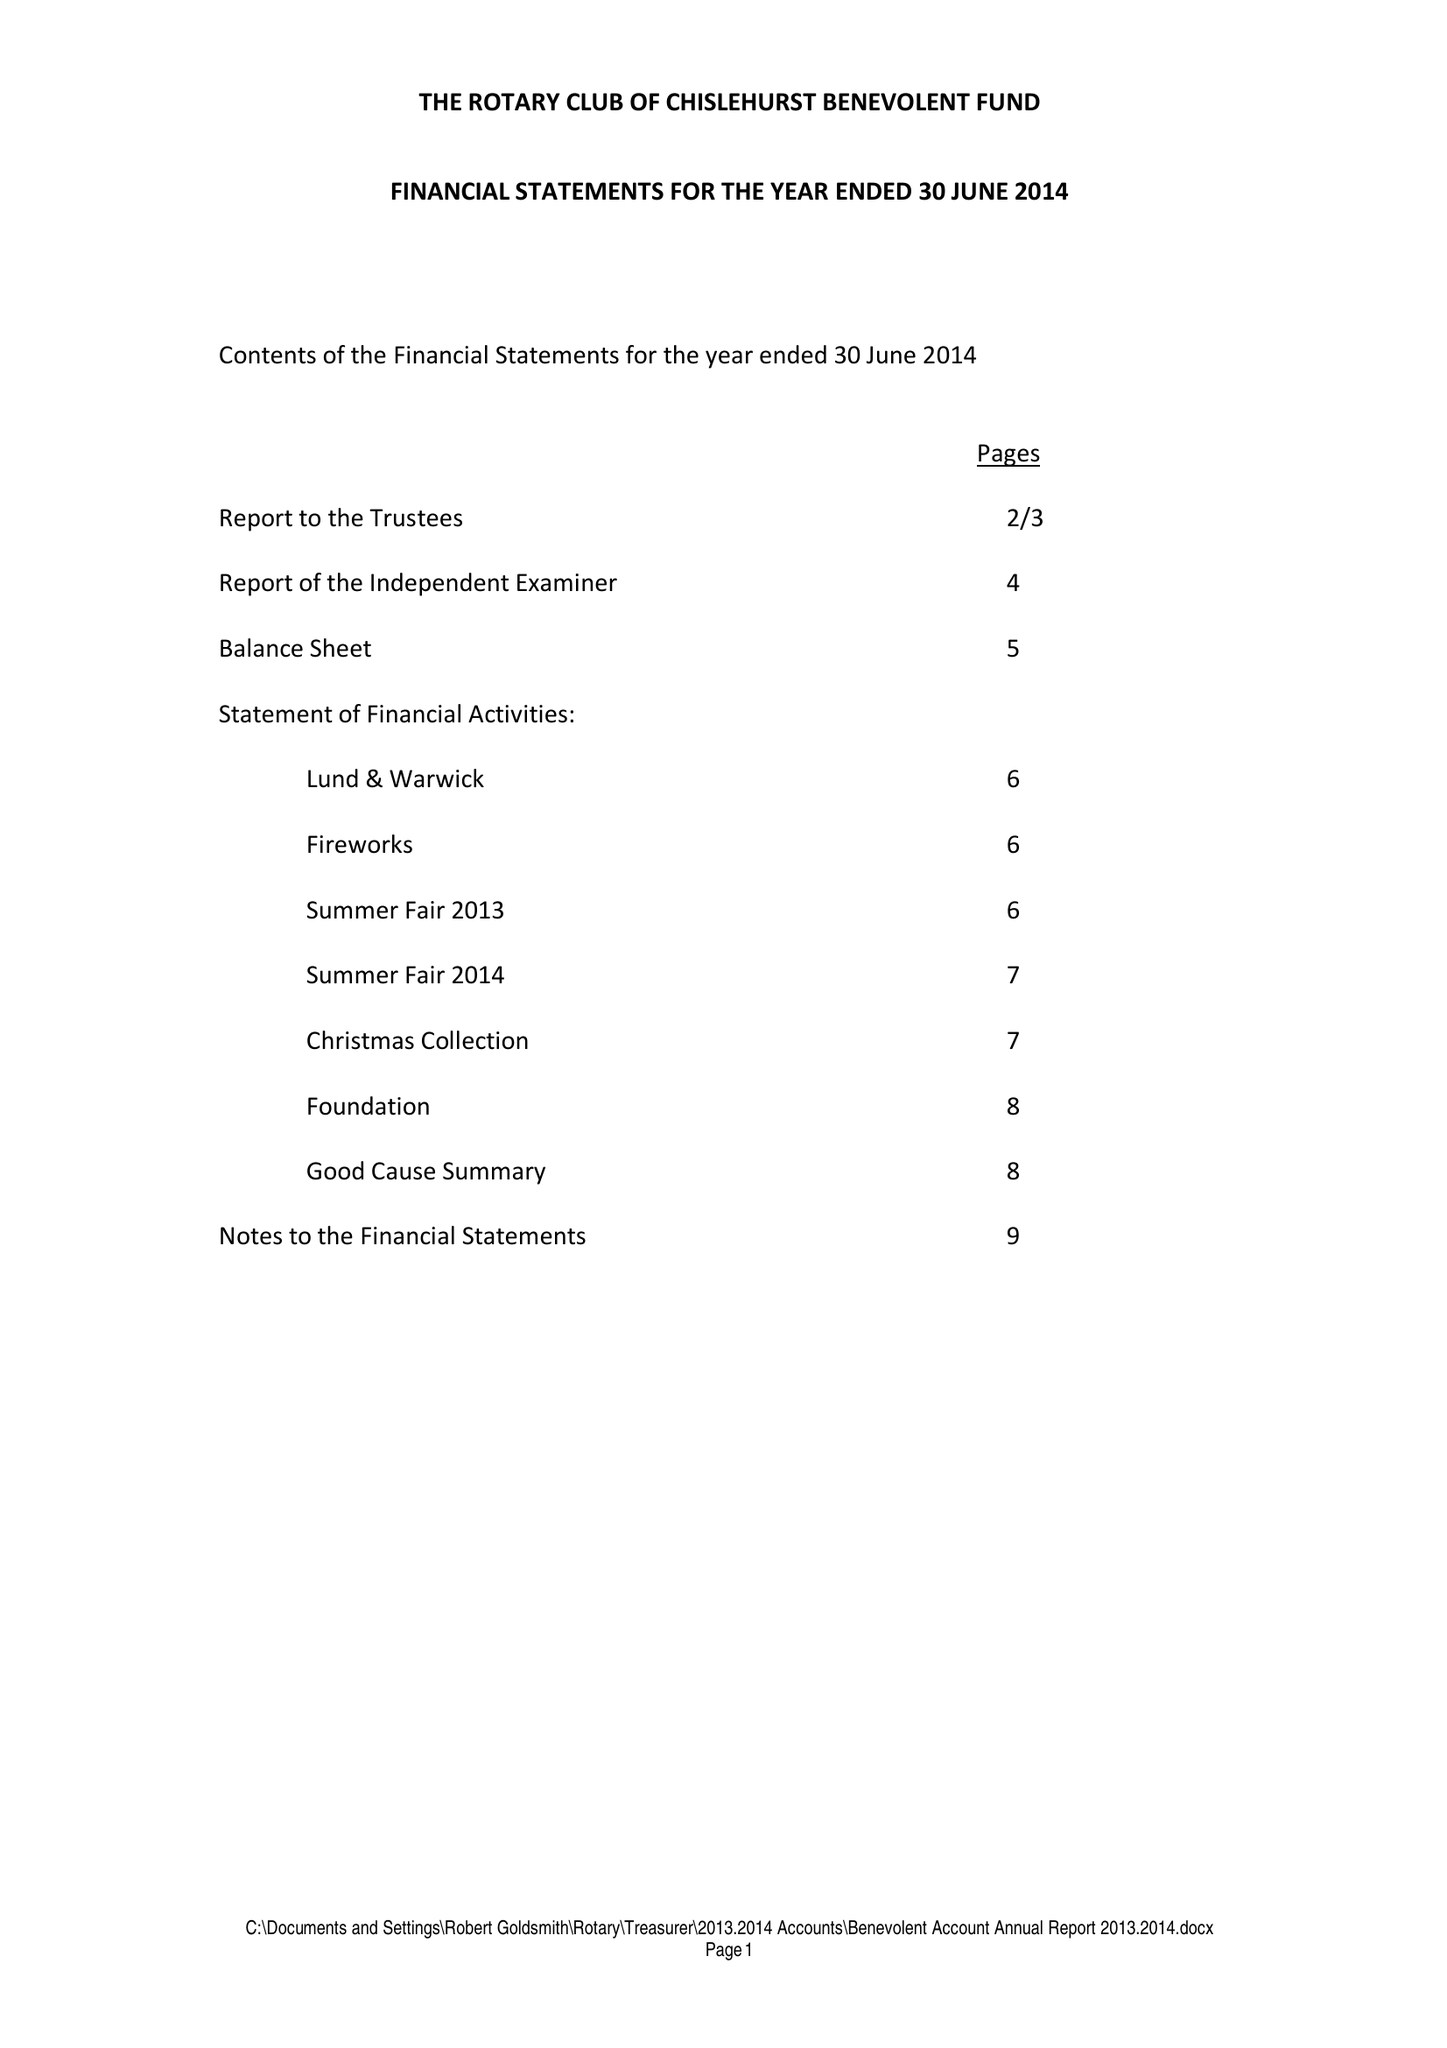What is the value for the address__postcode?
Answer the question using a single word or phrase. BR6 7RS 